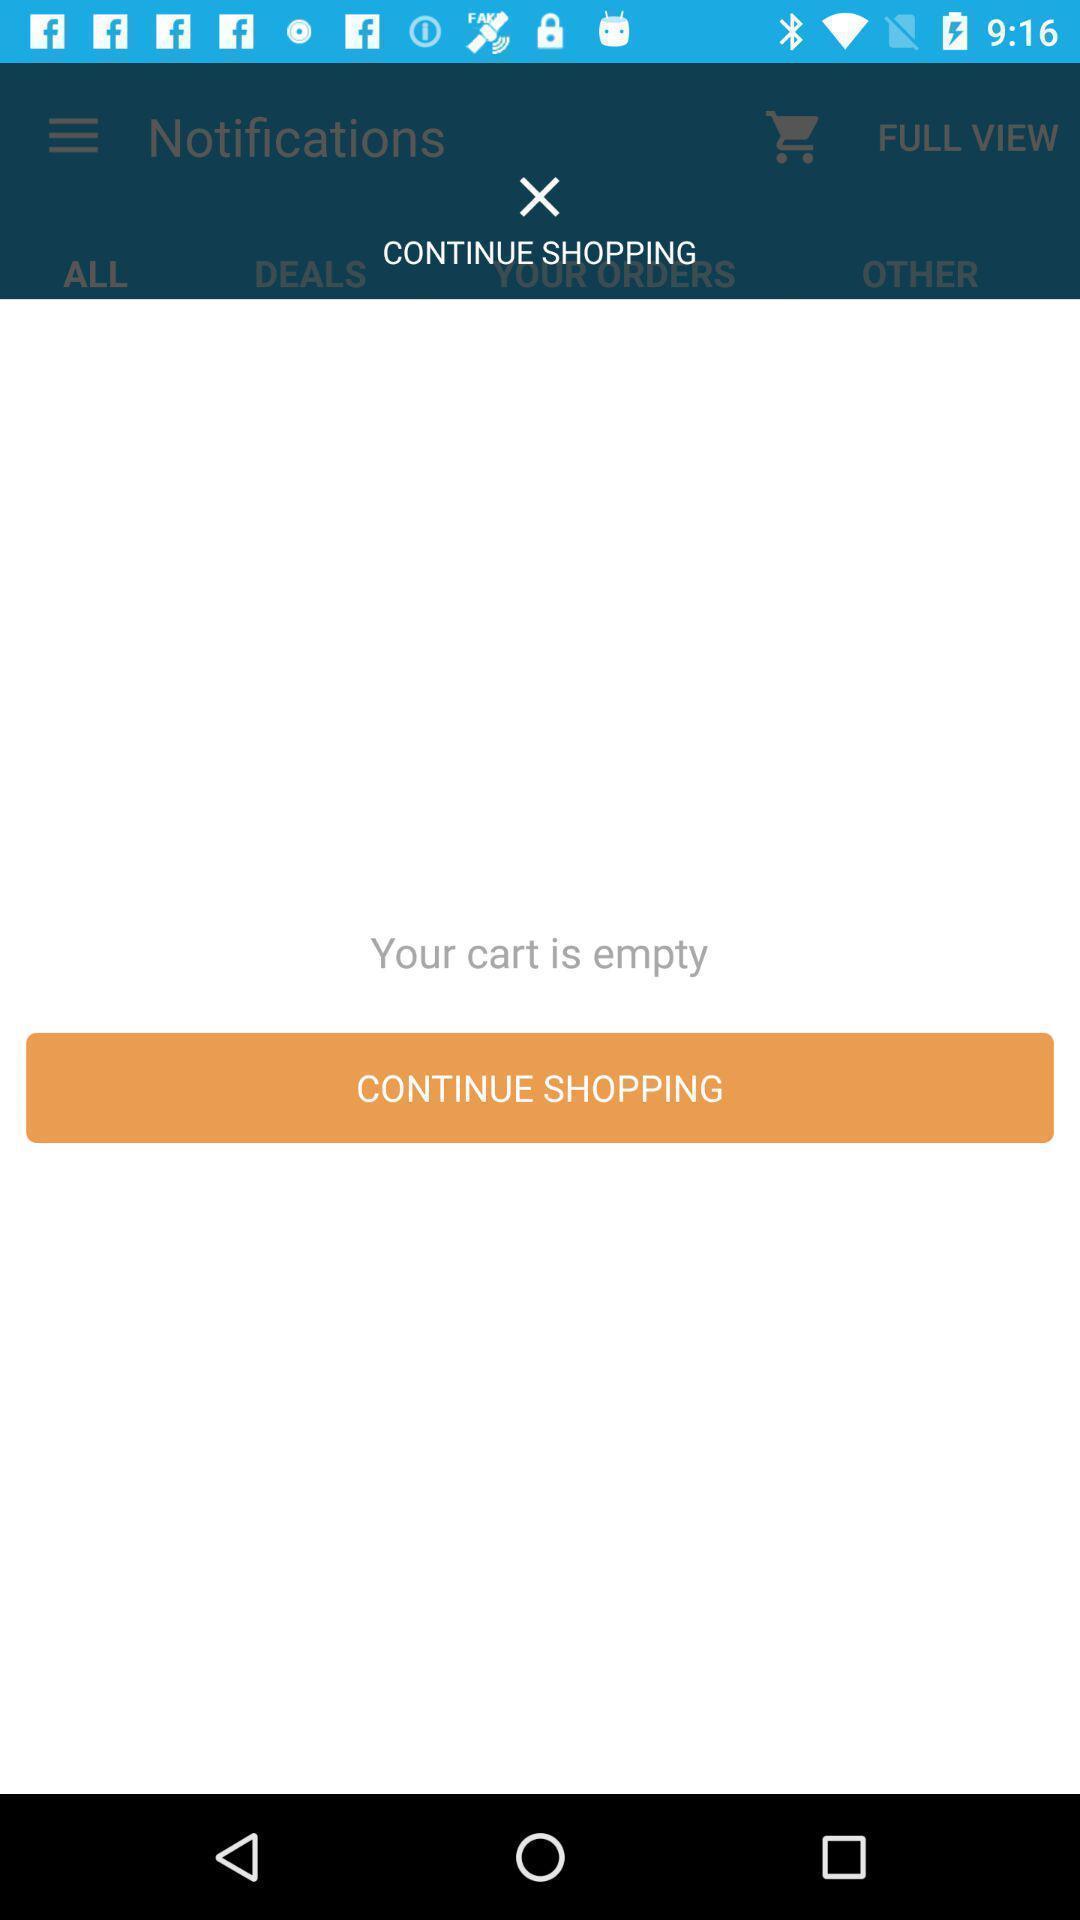Summarize the information in this screenshot. Pop-up window is showing no results. 